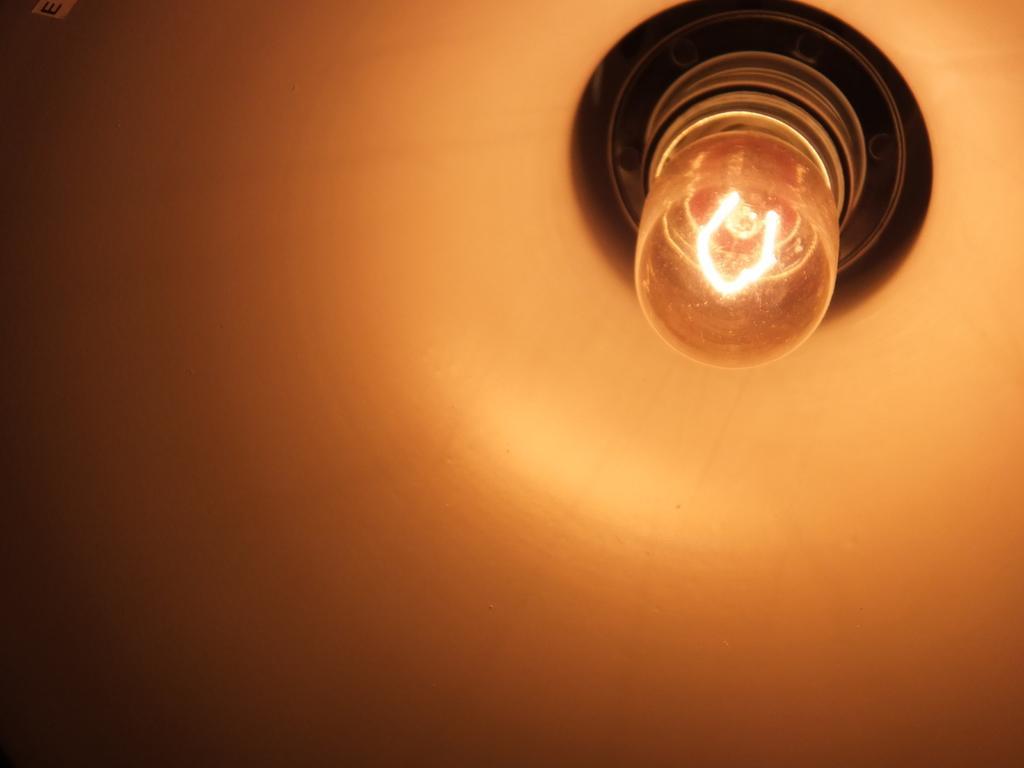In one or two sentences, can you explain what this image depicts? In this image there is a light. 